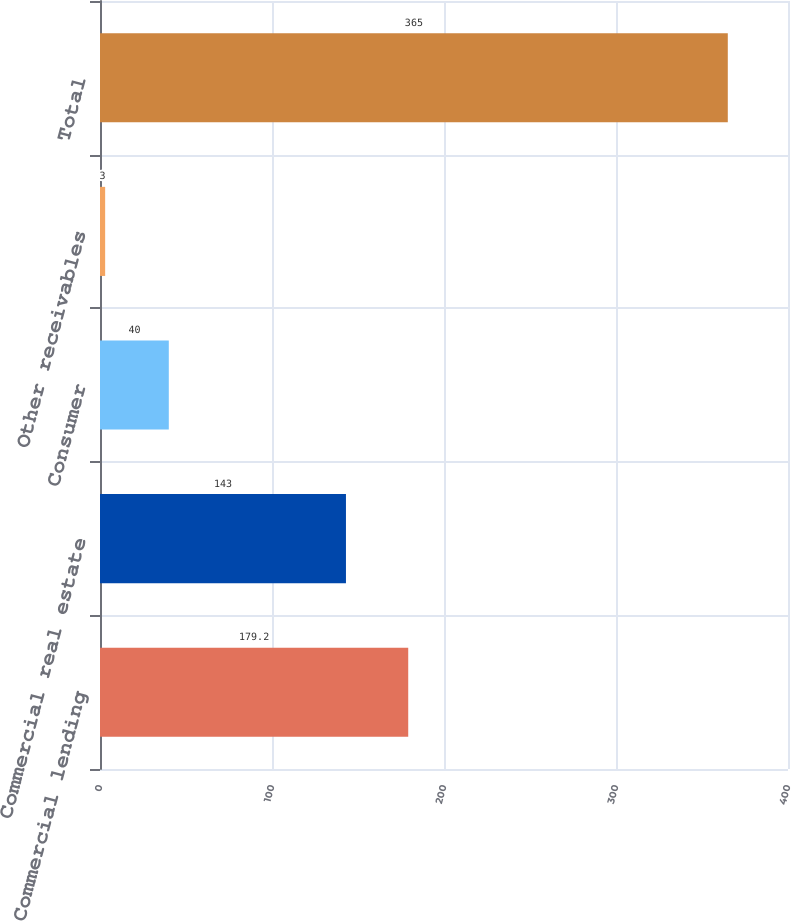<chart> <loc_0><loc_0><loc_500><loc_500><bar_chart><fcel>Commercial lending<fcel>Commercial real estate<fcel>Consumer<fcel>Other receivables<fcel>Total<nl><fcel>179.2<fcel>143<fcel>40<fcel>3<fcel>365<nl></chart> 